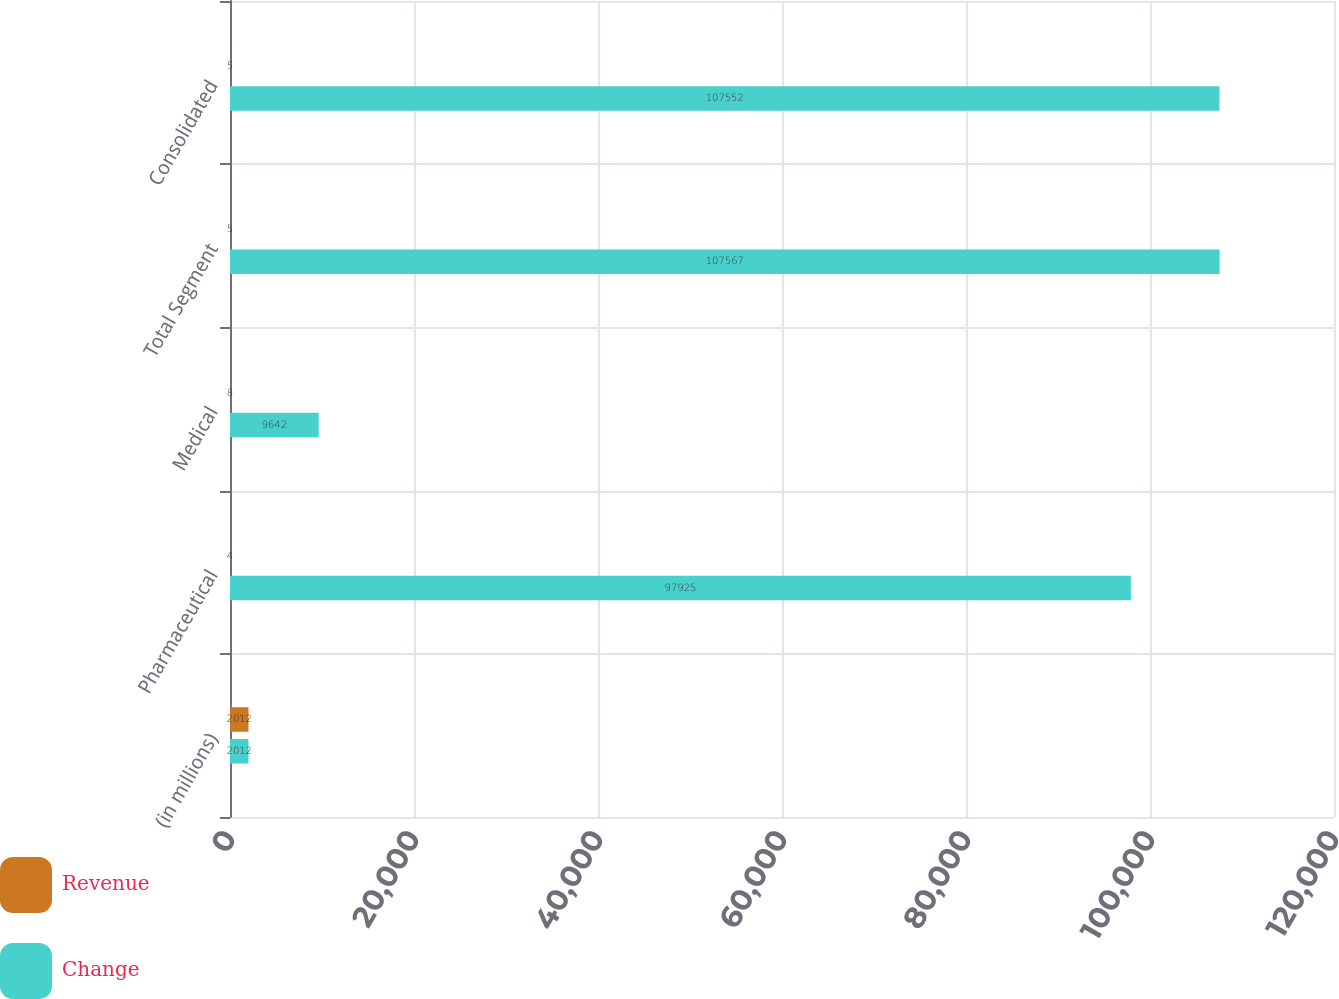Convert chart. <chart><loc_0><loc_0><loc_500><loc_500><stacked_bar_chart><ecel><fcel>(in millions)<fcel>Pharmaceutical<fcel>Medical<fcel>Total Segment<fcel>Consolidated<nl><fcel>Revenue<fcel>2012<fcel>4<fcel>8<fcel>5<fcel>5<nl><fcel>Change<fcel>2012<fcel>97925<fcel>9642<fcel>107567<fcel>107552<nl></chart> 